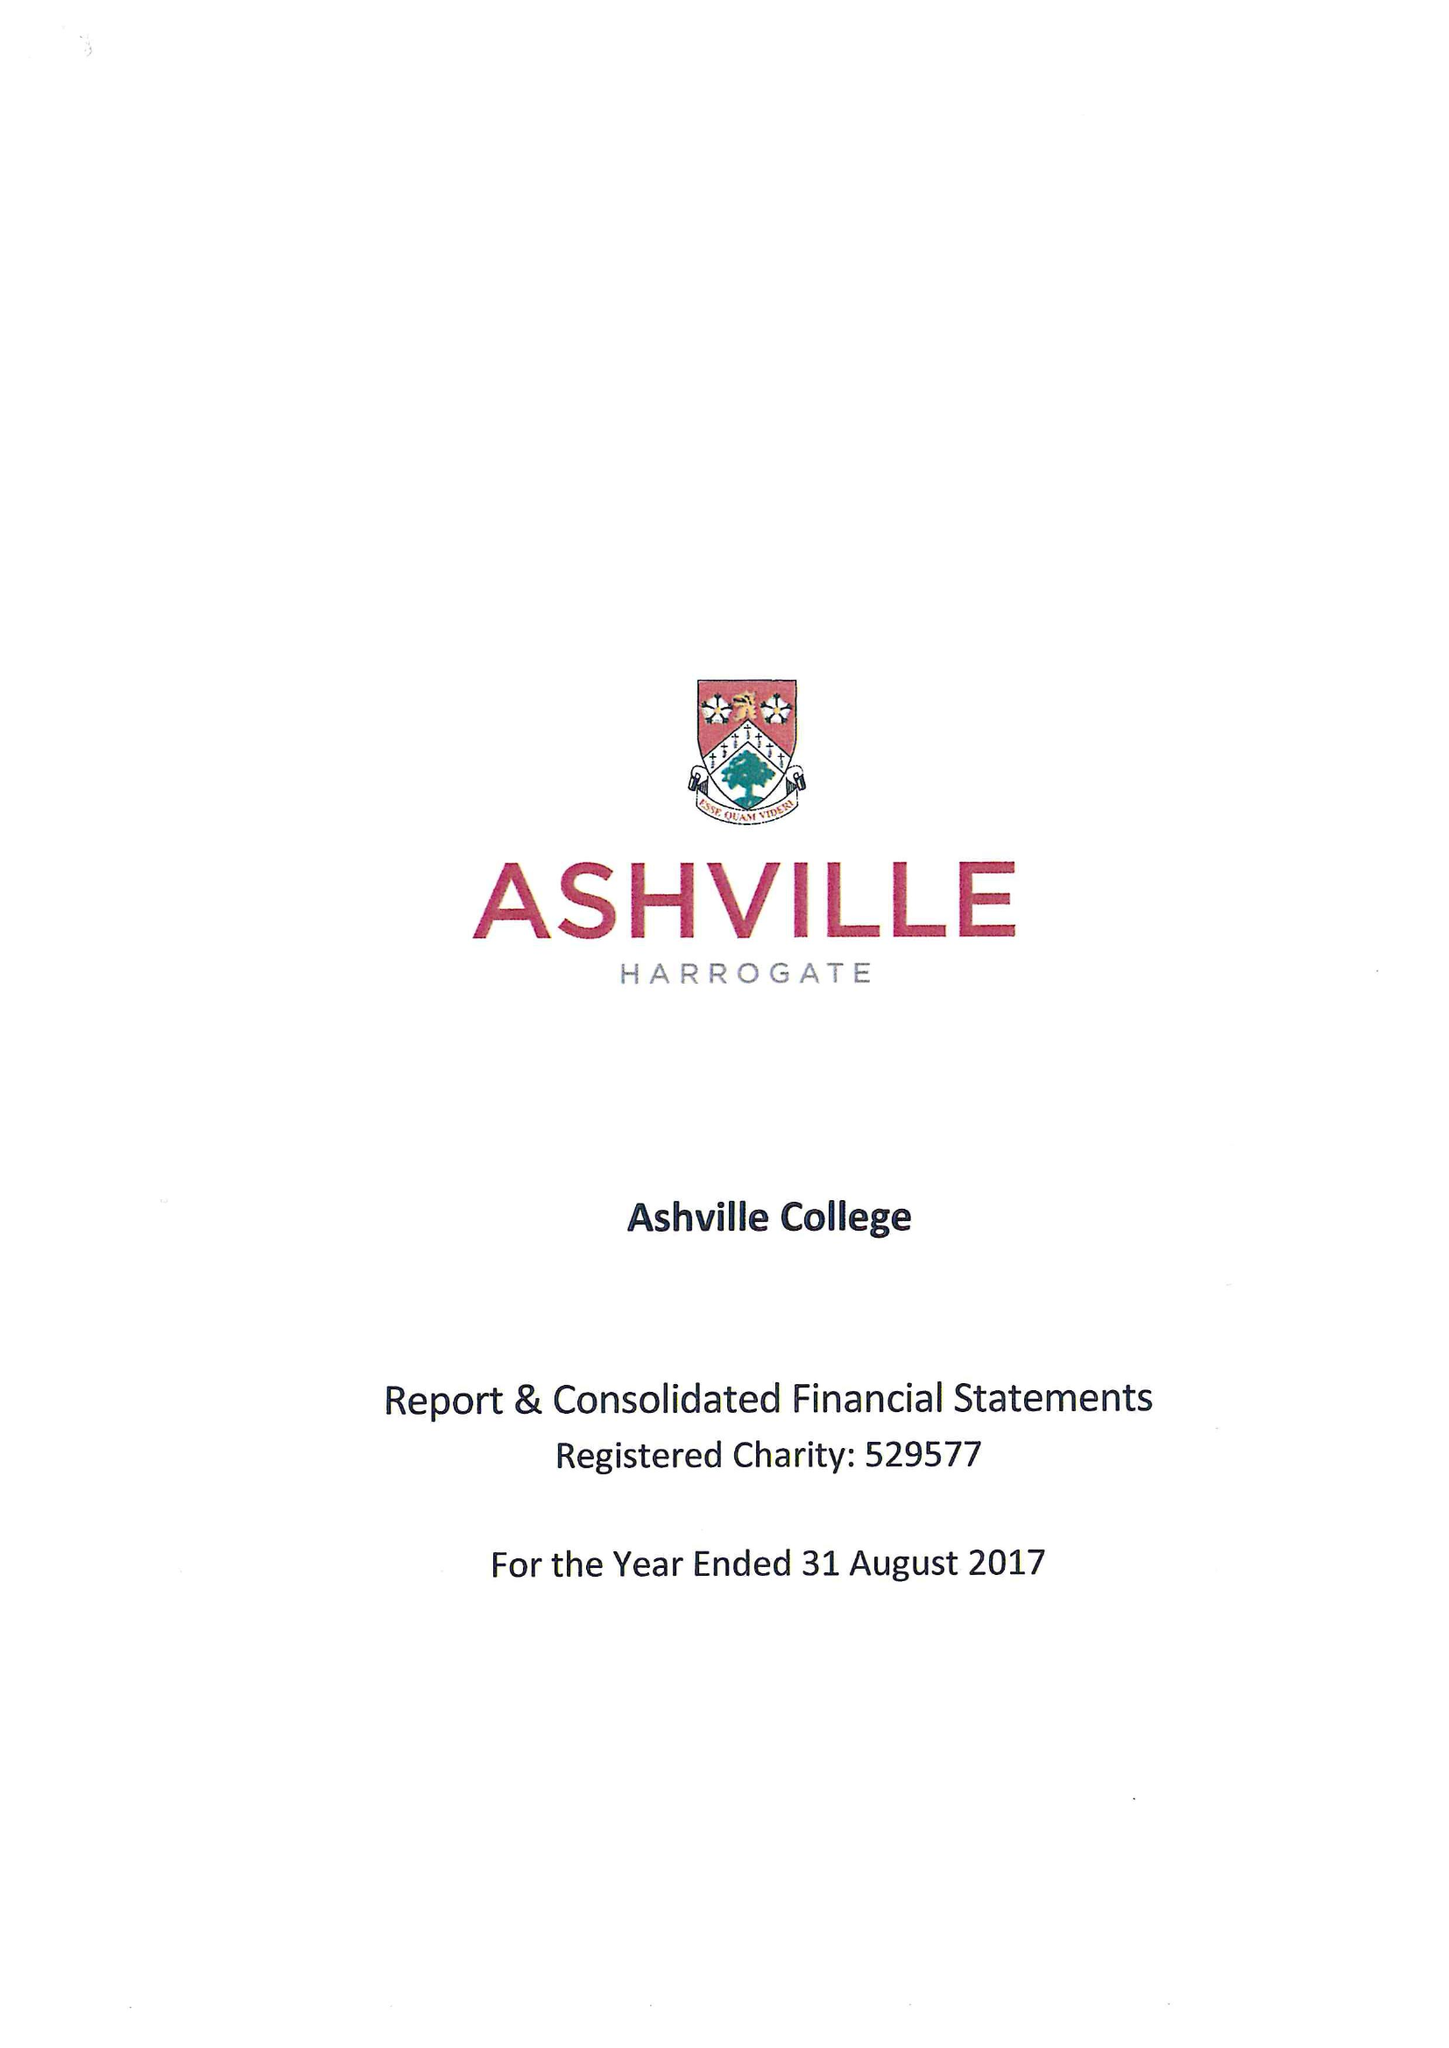What is the value for the address__post_town?
Answer the question using a single word or phrase. HARROGATE 